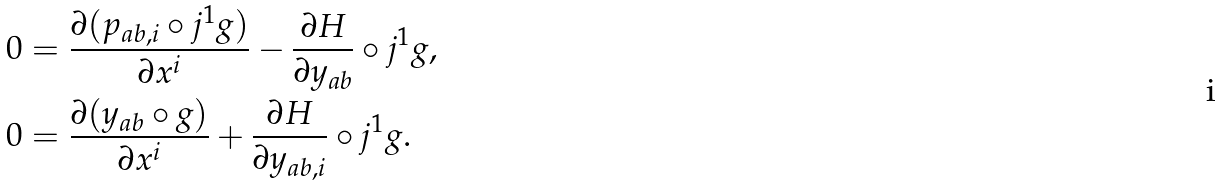<formula> <loc_0><loc_0><loc_500><loc_500>0 & = \frac { \partial ( p _ { a b , i } \circ j ^ { 1 } g ) } { \partial x ^ { i } } - \frac { \partial H } { \partial y _ { a b } } \circ j ^ { 1 } g , \\ 0 & = \frac { \partial ( y _ { a b } \circ g ) } { \partial x ^ { i } } + \frac { \partial H } { \partial y _ { a b , i } } \circ j ^ { 1 } g .</formula> 